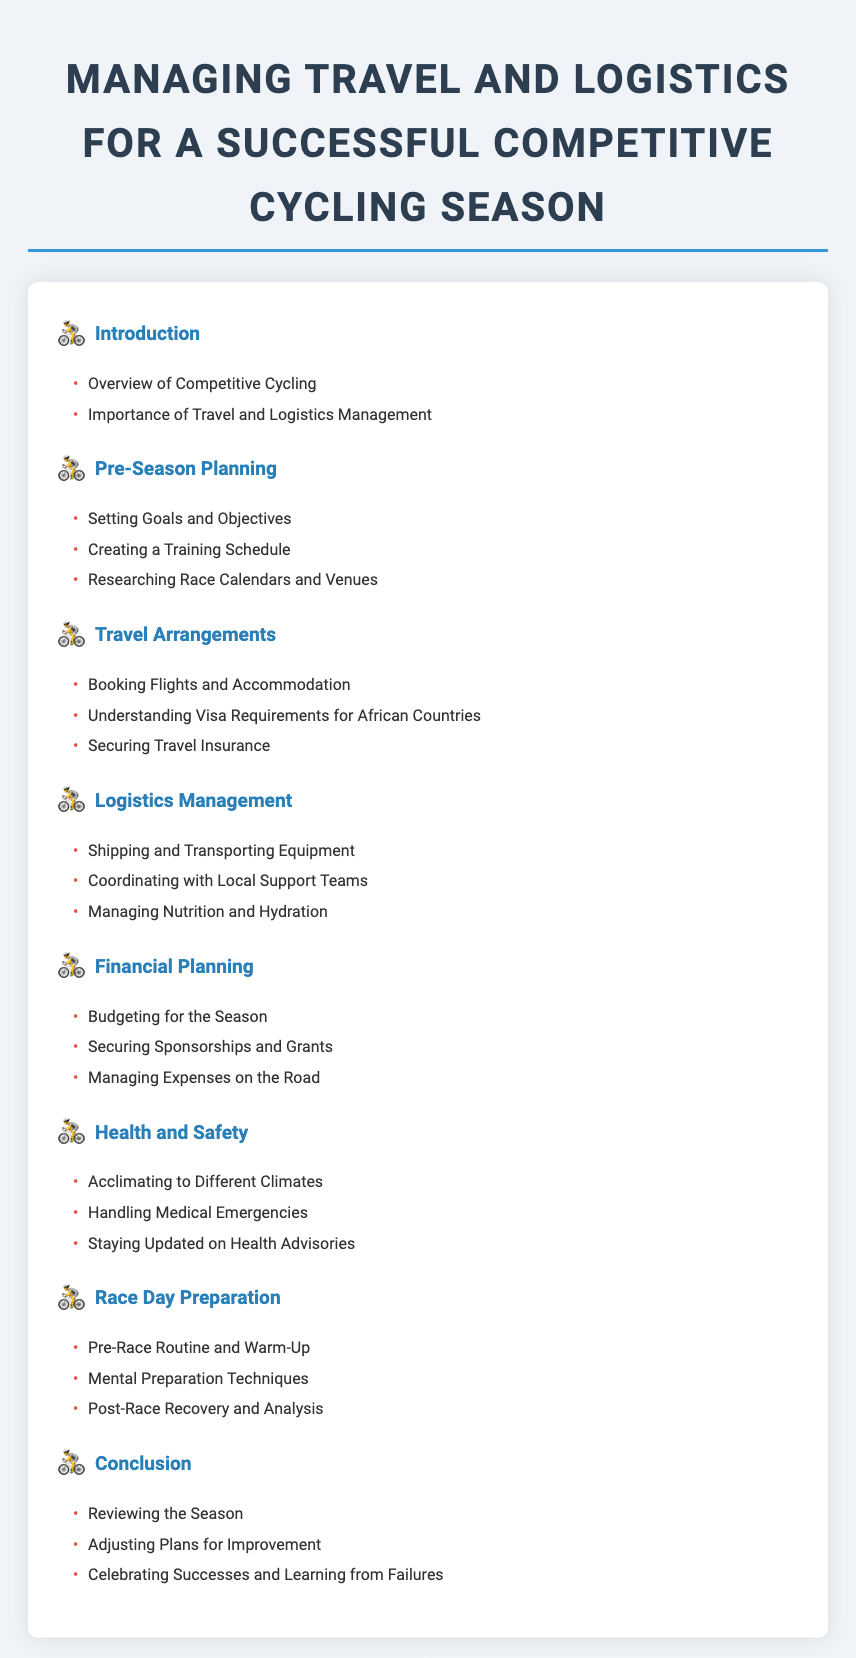What is the title of the document? The title of the document is stated at the beginning of the rendered content and indicates its main subject.
Answer: Managing Travel and Logistics for a Successful Competitive Cycling Season How many sections are in the Table of Contents? The sections of the Table of Contents are listed sequentially, allowing for a quick count of total sections.
Answer: 7 What is the first topic under Pre-Season Planning? The first topic listed under Pre-Season Planning can be directly found in the corresponding section of the Table of Contents.
Answer: Setting Goals and Objectives What is one aspect of Logistics Management? The aspect is found as one of the bullet points in the section dedicated to Logistics Management in the document.
Answer: Shipping and Transporting Equipment What is the last topic mentioned in the Conclusion? The last topic under the Conclusion section is available as the final item in that list.
Answer: Celebrating Successes and Learning from Failures What is the focus of the Health and Safety section? The section emphasizes key areas pertaining to the health and safety of athletes during their cycling season.
Answer: Acclimating to Different Climates How many topics are listed under Travel Arrangements? The topics under Travel Arrangements can be enumerated from the associated bullet points in that specific section.
Answer: 3 What is the main purpose highlighted in the Introduction? The purpose is indicated in the description provided under the Introduction section.
Answer: Importance of Travel and Logistics Management 